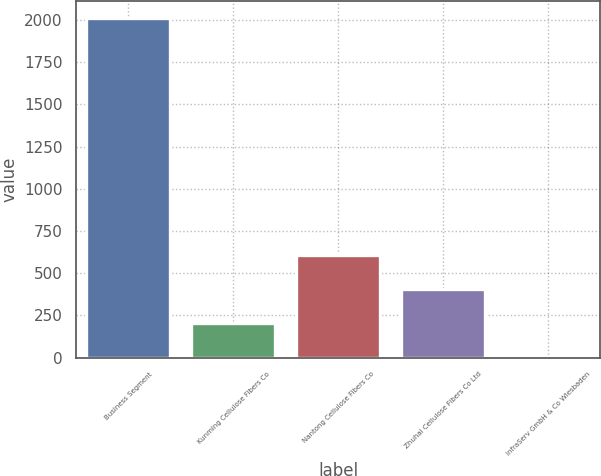<chart> <loc_0><loc_0><loc_500><loc_500><bar_chart><fcel>Business Segment<fcel>Kunming Cellulose Fibers Co<fcel>Nantong Cellulose Fibers Co<fcel>Zhuhai Cellulose Fibers Co Ltd<fcel>InfraServ GmbH & Co Wiesbaden<nl><fcel>2010<fcel>206.4<fcel>607.2<fcel>406.8<fcel>6<nl></chart> 